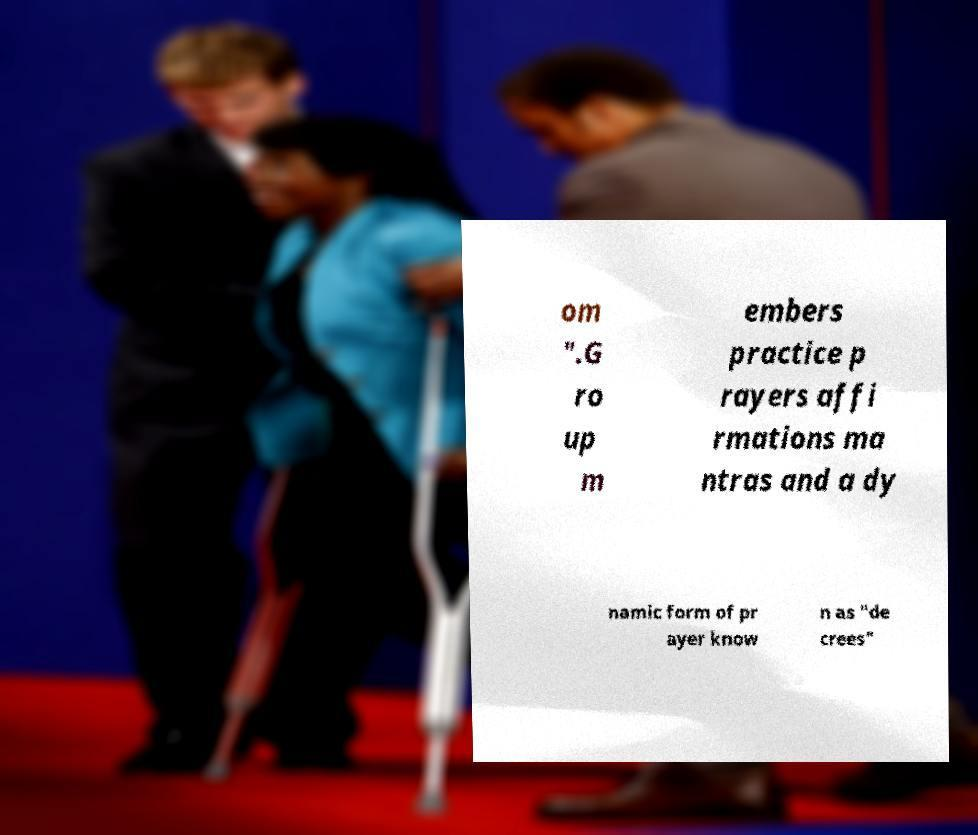Please identify and transcribe the text found in this image. om ".G ro up m embers practice p rayers affi rmations ma ntras and a dy namic form of pr ayer know n as "de crees" 